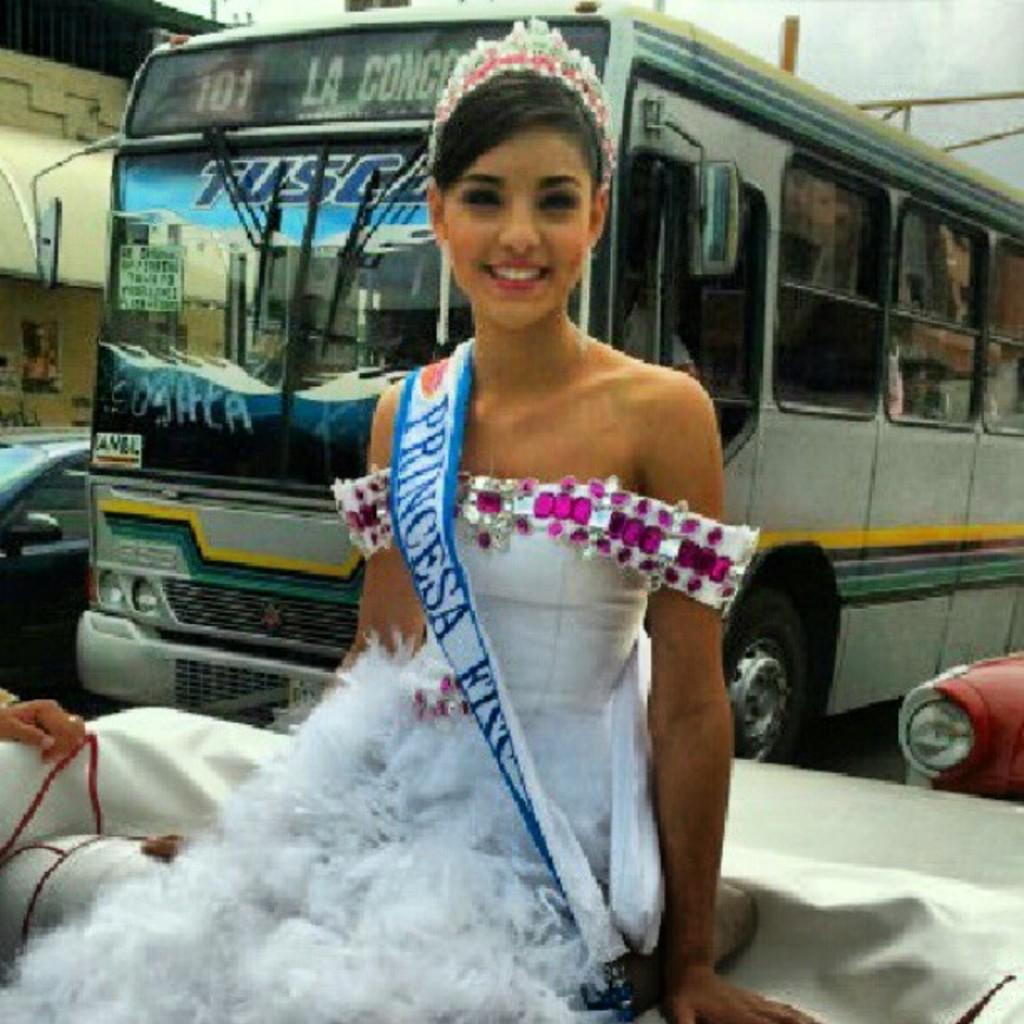Who is the main subject in the foreground of the image? There is a lady in the foreground of the image. What is the lady doing in the image? The lady is sitting. What is the lady wearing in the image? The lady is wearing a white gown and a crown. What is the lady's facial expression in the image? The lady is smiling. What can be seen in the background of the image? There are vehicles in the background of the image. Can you tell me how the boat is affected by friction in the image? There is no boat present in the image, so the question about friction cannot be answered. 